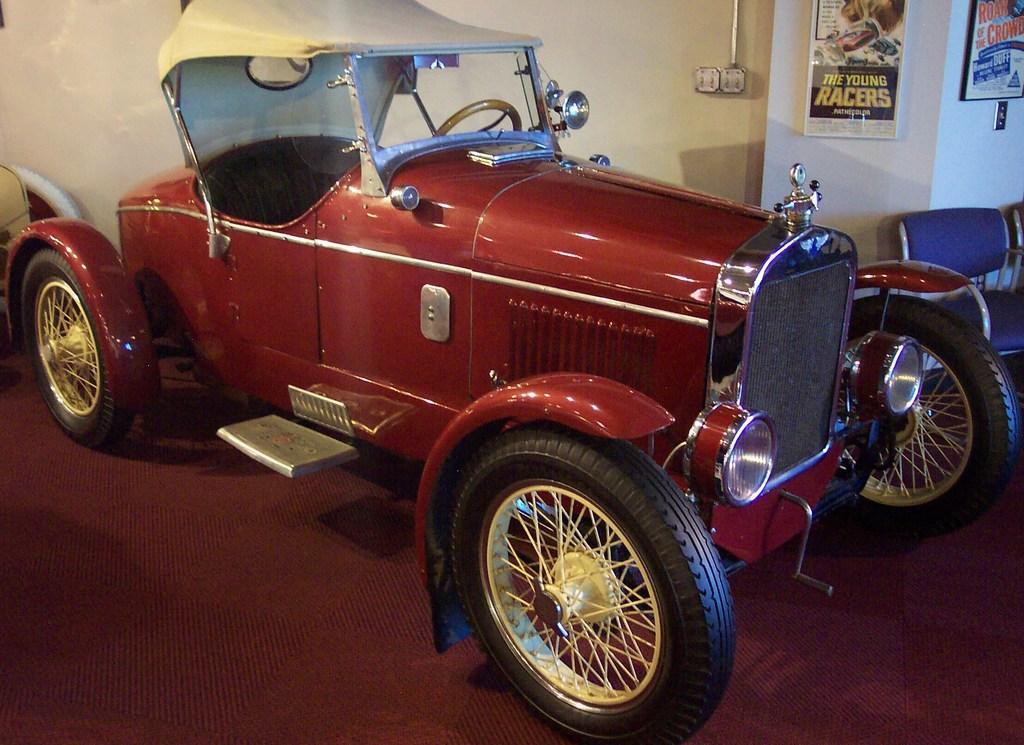Can you describe this image briefly? In the center of the image, there is a car and on the right, there are chairs. In the background, we can see posts placed on the wall. 